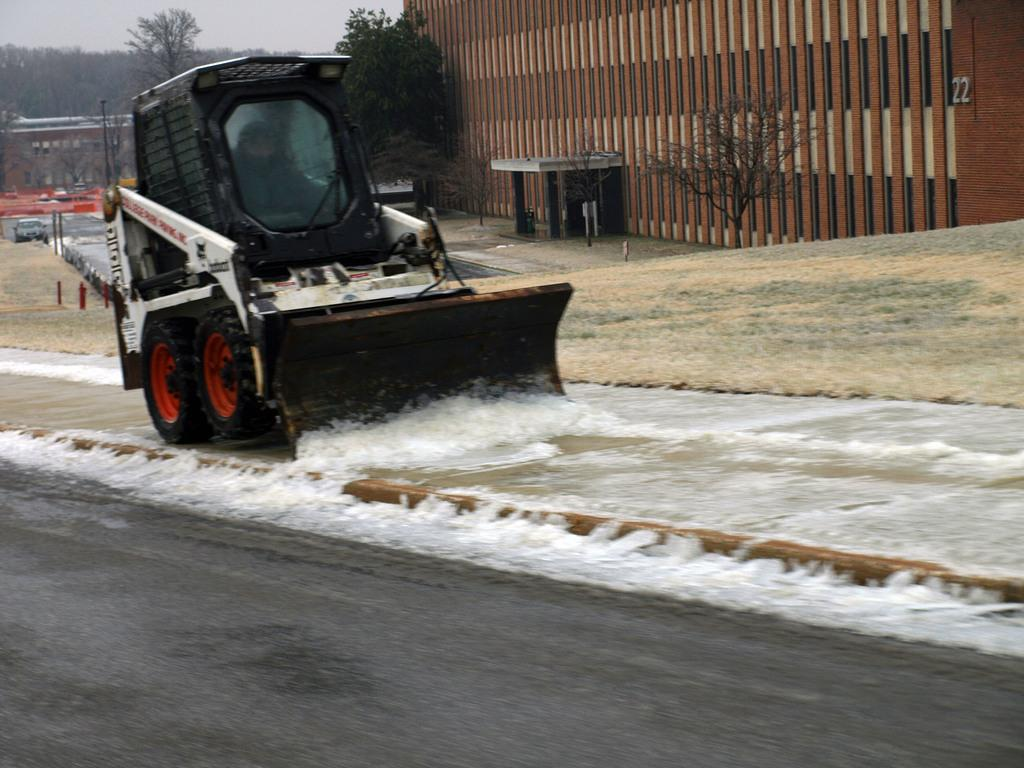What type of structures can be seen in the image? There are buildings in the image. What other natural elements are present in the image? There are trees in the image. What type of construction equipment is visible in the image? There is a bulldozer in the image. What is the condition of the ground in the image? There is snow on the ground in the image. What type of vehicle is present in the image? There is a vehicle in the image. How would you describe the weather in the image? The sky is cloudy in the image. What type of card is being used to shovel the snow in the image? There is no card present in the image, and the bulldozer is being used to move the snow, not a card. 